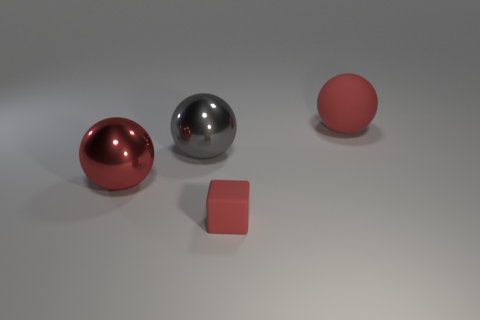Add 2 large red matte balls. How many objects exist? 6 Subtract all cubes. How many objects are left? 3 Add 1 big red spheres. How many big red spheres exist? 3 Subtract 0 green cubes. How many objects are left? 4 Subtract all big red rubber things. Subtract all large gray balls. How many objects are left? 2 Add 1 large gray balls. How many large gray balls are left? 2 